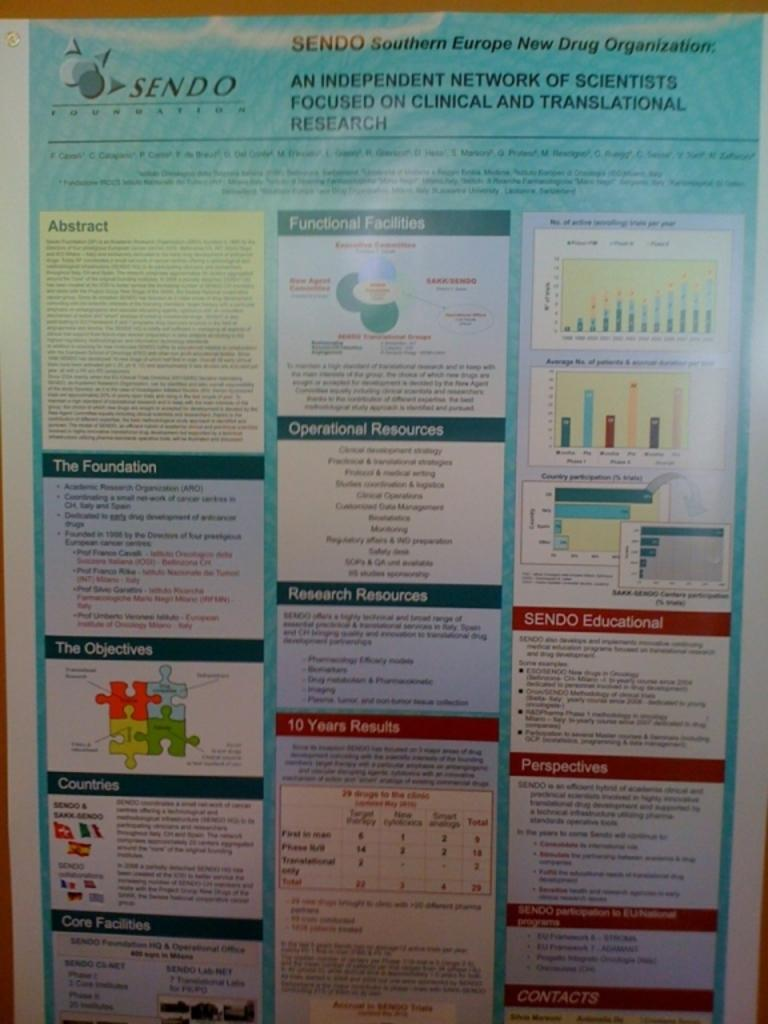<image>
Render a clear and concise summary of the photo. Poster on a call for the brand Sendo. 